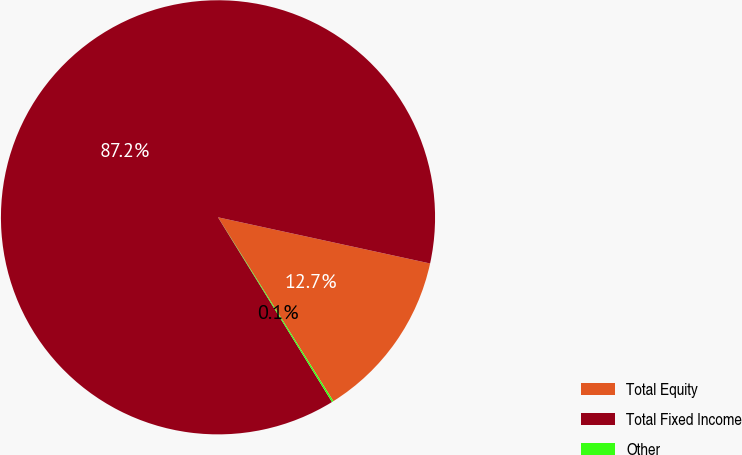Convert chart. <chart><loc_0><loc_0><loc_500><loc_500><pie_chart><fcel>Total Equity<fcel>Total Fixed Income<fcel>Other<nl><fcel>12.67%<fcel>87.21%<fcel>0.12%<nl></chart> 